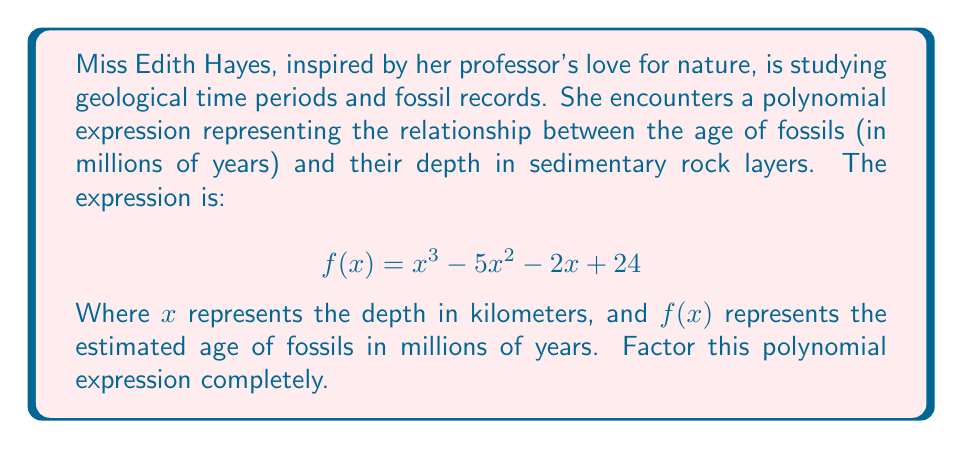Show me your answer to this math problem. To factor this polynomial, we'll follow these steps:

1) First, let's check if there's a common factor. In this case, there isn't.

2) Next, we'll try to guess one factor. A good approach is to look at the possible factors of the constant term (24). The factors of 24 are: ±1, ±2, ±3, ±4, ±6, ±8, ±12, ±24.

3) We can use the rational root theorem to test these values. After testing, we find that $(x - 4)$ is a factor.

4) We can use polynomial long division to divide $f(x)$ by $(x - 4)$:

   $$ x^3 - 5x^2 - 2x + 24 = (x - 4)(x^2 - x - 6) $$

5) Now we need to factor the quadratic expression $x^2 - x - 6$. We can do this by finding two numbers that multiply to give -6 and add to give -1. These numbers are -3 and 2.

6) Therefore, $x^2 - x - 6 = (x - 3)(x + 2)$

7) Combining all factors, we get:

   $$ f(x) = (x - 4)(x - 3)(x + 2) $$

This factorization reveals that fossils are estimated to be 0 million years old at depths of 4 km, 3 km, and -2 km (which is not physically meaningful but mathematically correct).
Answer: $$ f(x) = (x - 4)(x - 3)(x + 2) $$ 